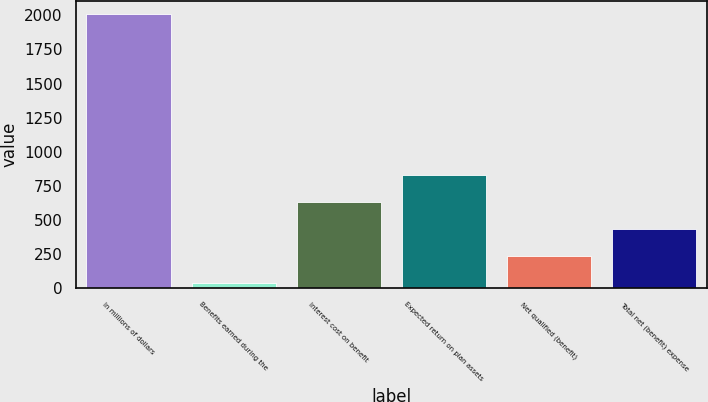<chart> <loc_0><loc_0><loc_500><loc_500><bar_chart><fcel>In millions of dollars<fcel>Benefits earned during the<fcel>Interest cost on benefit<fcel>Expected return on plan assets<fcel>Net qualified (benefit)<fcel>Total net (benefit) expense<nl><fcel>2008<fcel>36<fcel>627.6<fcel>824.8<fcel>233.2<fcel>430.4<nl></chart> 